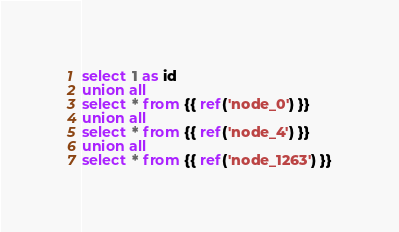Convert code to text. <code><loc_0><loc_0><loc_500><loc_500><_SQL_>select 1 as id
union all
select * from {{ ref('node_0') }}
union all
select * from {{ ref('node_4') }}
union all
select * from {{ ref('node_1263') }}
</code> 